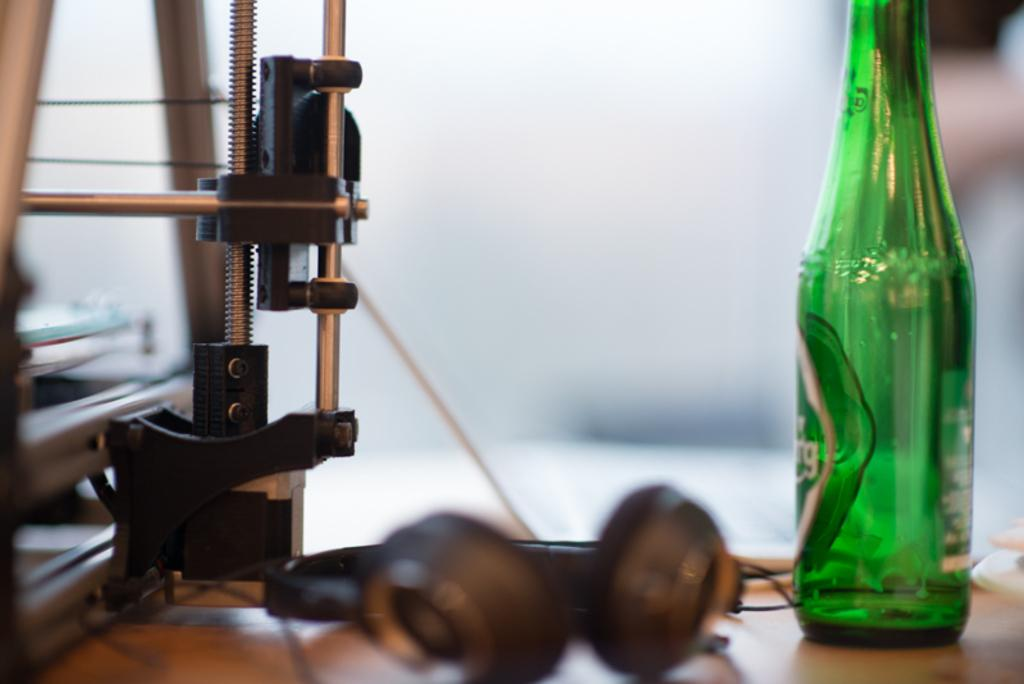What can be observed about the background of the image? The background of the image is blurred. What type of objects are present in the image? There is equipment and headsets visible in the image. Can you describe the color of the bottle on the table? There is a green-colored bottle on the table. What story is being told by the army in the image? There is no army or story present in the image; it features equipment and headsets. How does the water in the image contribute to the scene? There is no water present in the image. 